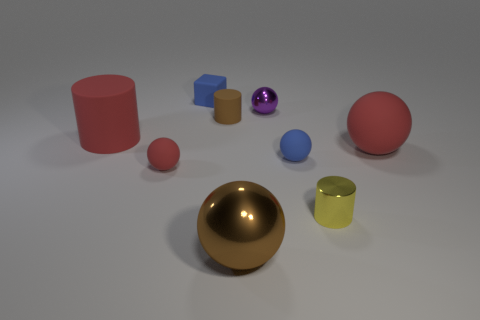What is the material of the thing that is the same color as the tiny cube?
Your answer should be compact. Rubber. There is a cylinder that is the same size as the brown sphere; what is its material?
Offer a very short reply. Rubber. Is the brown object behind the brown metallic sphere made of the same material as the small blue object that is in front of the small blue rubber cube?
Give a very brief answer. Yes. What is the shape of the purple metallic object that is the same size as the brown rubber cylinder?
Your answer should be compact. Sphere. How many other things are the same color as the large metallic thing?
Your answer should be compact. 1. There is a cylinder on the left side of the tiny red ball; what color is it?
Provide a short and direct response. Red. How many other things are there of the same material as the blue block?
Make the answer very short. 5. Are there more large red rubber things in front of the tiny blue cube than tiny red matte balls behind the red cylinder?
Ensure brevity in your answer.  Yes. There is a small matte cylinder; what number of small shiny objects are behind it?
Provide a succinct answer. 1. Are the small blue sphere and the brown thing to the right of the brown cylinder made of the same material?
Make the answer very short. No. 